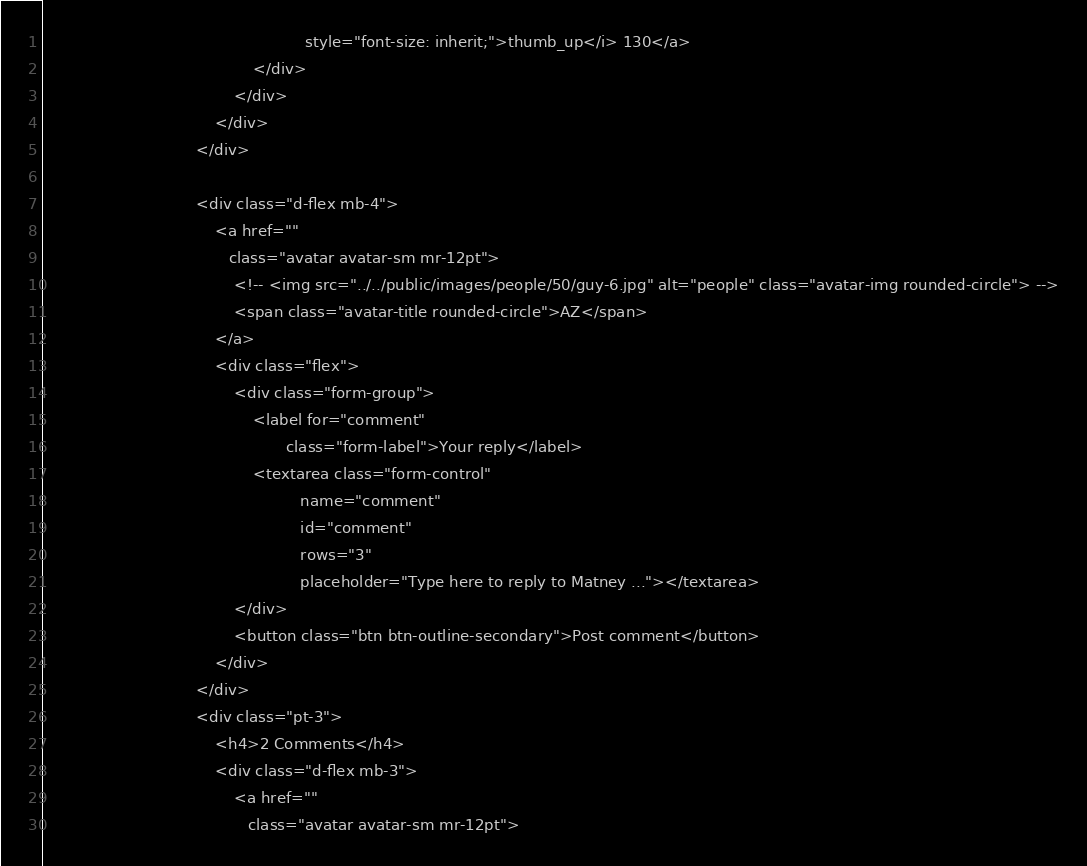<code> <loc_0><loc_0><loc_500><loc_500><_PHP_>                                                       style="font-size: inherit;">thumb_up</i> 130</a>
                                            </div>
                                        </div>
                                    </div>
                                </div>

                                <div class="d-flex mb-4">
                                    <a href=""
                                       class="avatar avatar-sm mr-12pt">
                                        <!-- <img src="../../public/images/people/50/guy-6.jpg" alt="people" class="avatar-img rounded-circle"> -->
                                        <span class="avatar-title rounded-circle">AZ</span>
                                    </a>
                                    <div class="flex">
                                        <div class="form-group">
                                            <label for="comment"
                                                   class="form-label">Your reply</label>
                                            <textarea class="form-control"
                                                      name="comment"
                                                      id="comment"
                                                      rows="3"
                                                      placeholder="Type here to reply to Matney ..."></textarea>
                                        </div>
                                        <button class="btn btn-outline-secondary">Post comment</button>
                                    </div>
                                </div>
                                <div class="pt-3">
                                    <h4>2 Comments</h4>
                                    <div class="d-flex mb-3">
                                        <a href=""
                                           class="avatar avatar-sm mr-12pt"></code> 